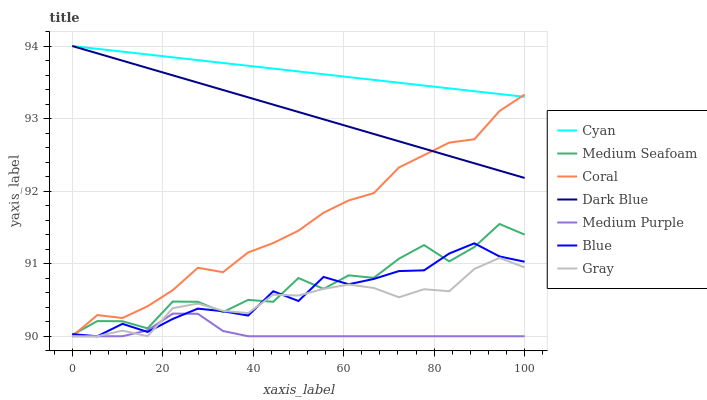Does Gray have the minimum area under the curve?
Answer yes or no. No. Does Gray have the maximum area under the curve?
Answer yes or no. No. Is Gray the smoothest?
Answer yes or no. No. Is Gray the roughest?
Answer yes or no. No. Does Dark Blue have the lowest value?
Answer yes or no. No. Does Gray have the highest value?
Answer yes or no. No. Is Blue less than Dark Blue?
Answer yes or no. Yes. Is Cyan greater than Medium Seafoam?
Answer yes or no. Yes. Does Blue intersect Dark Blue?
Answer yes or no. No. 